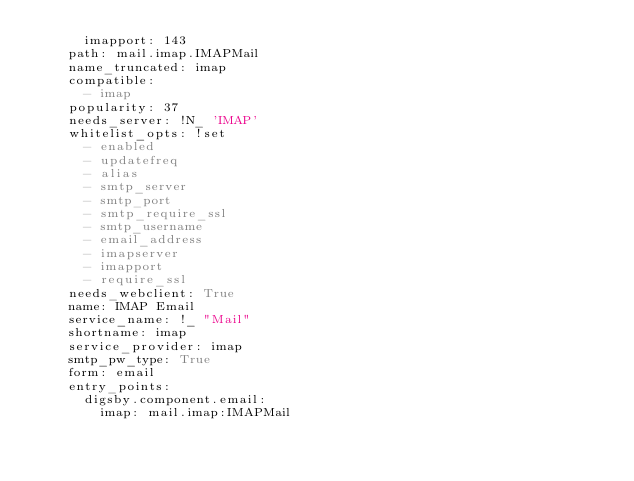Convert code to text. <code><loc_0><loc_0><loc_500><loc_500><_YAML_>      imapport: 143
    path: mail.imap.IMAPMail
    name_truncated: imap
    compatible:
      - imap
    popularity: 37
    needs_server: !N_ 'IMAP'
    whitelist_opts: !set
      - enabled
      - updatefreq
      - alias
      - smtp_server
      - smtp_port
      - smtp_require_ssl
      - smtp_username
      - email_address
      - imapserver
      - imapport
      - require_ssl
    needs_webclient: True
    name: IMAP Email
    service_name: !_ "Mail"
    shortname: imap
    service_provider: imap
    smtp_pw_type: True
    form: email
    entry_points:
      digsby.component.email:
        imap: mail.imap:IMAPMail
</code> 